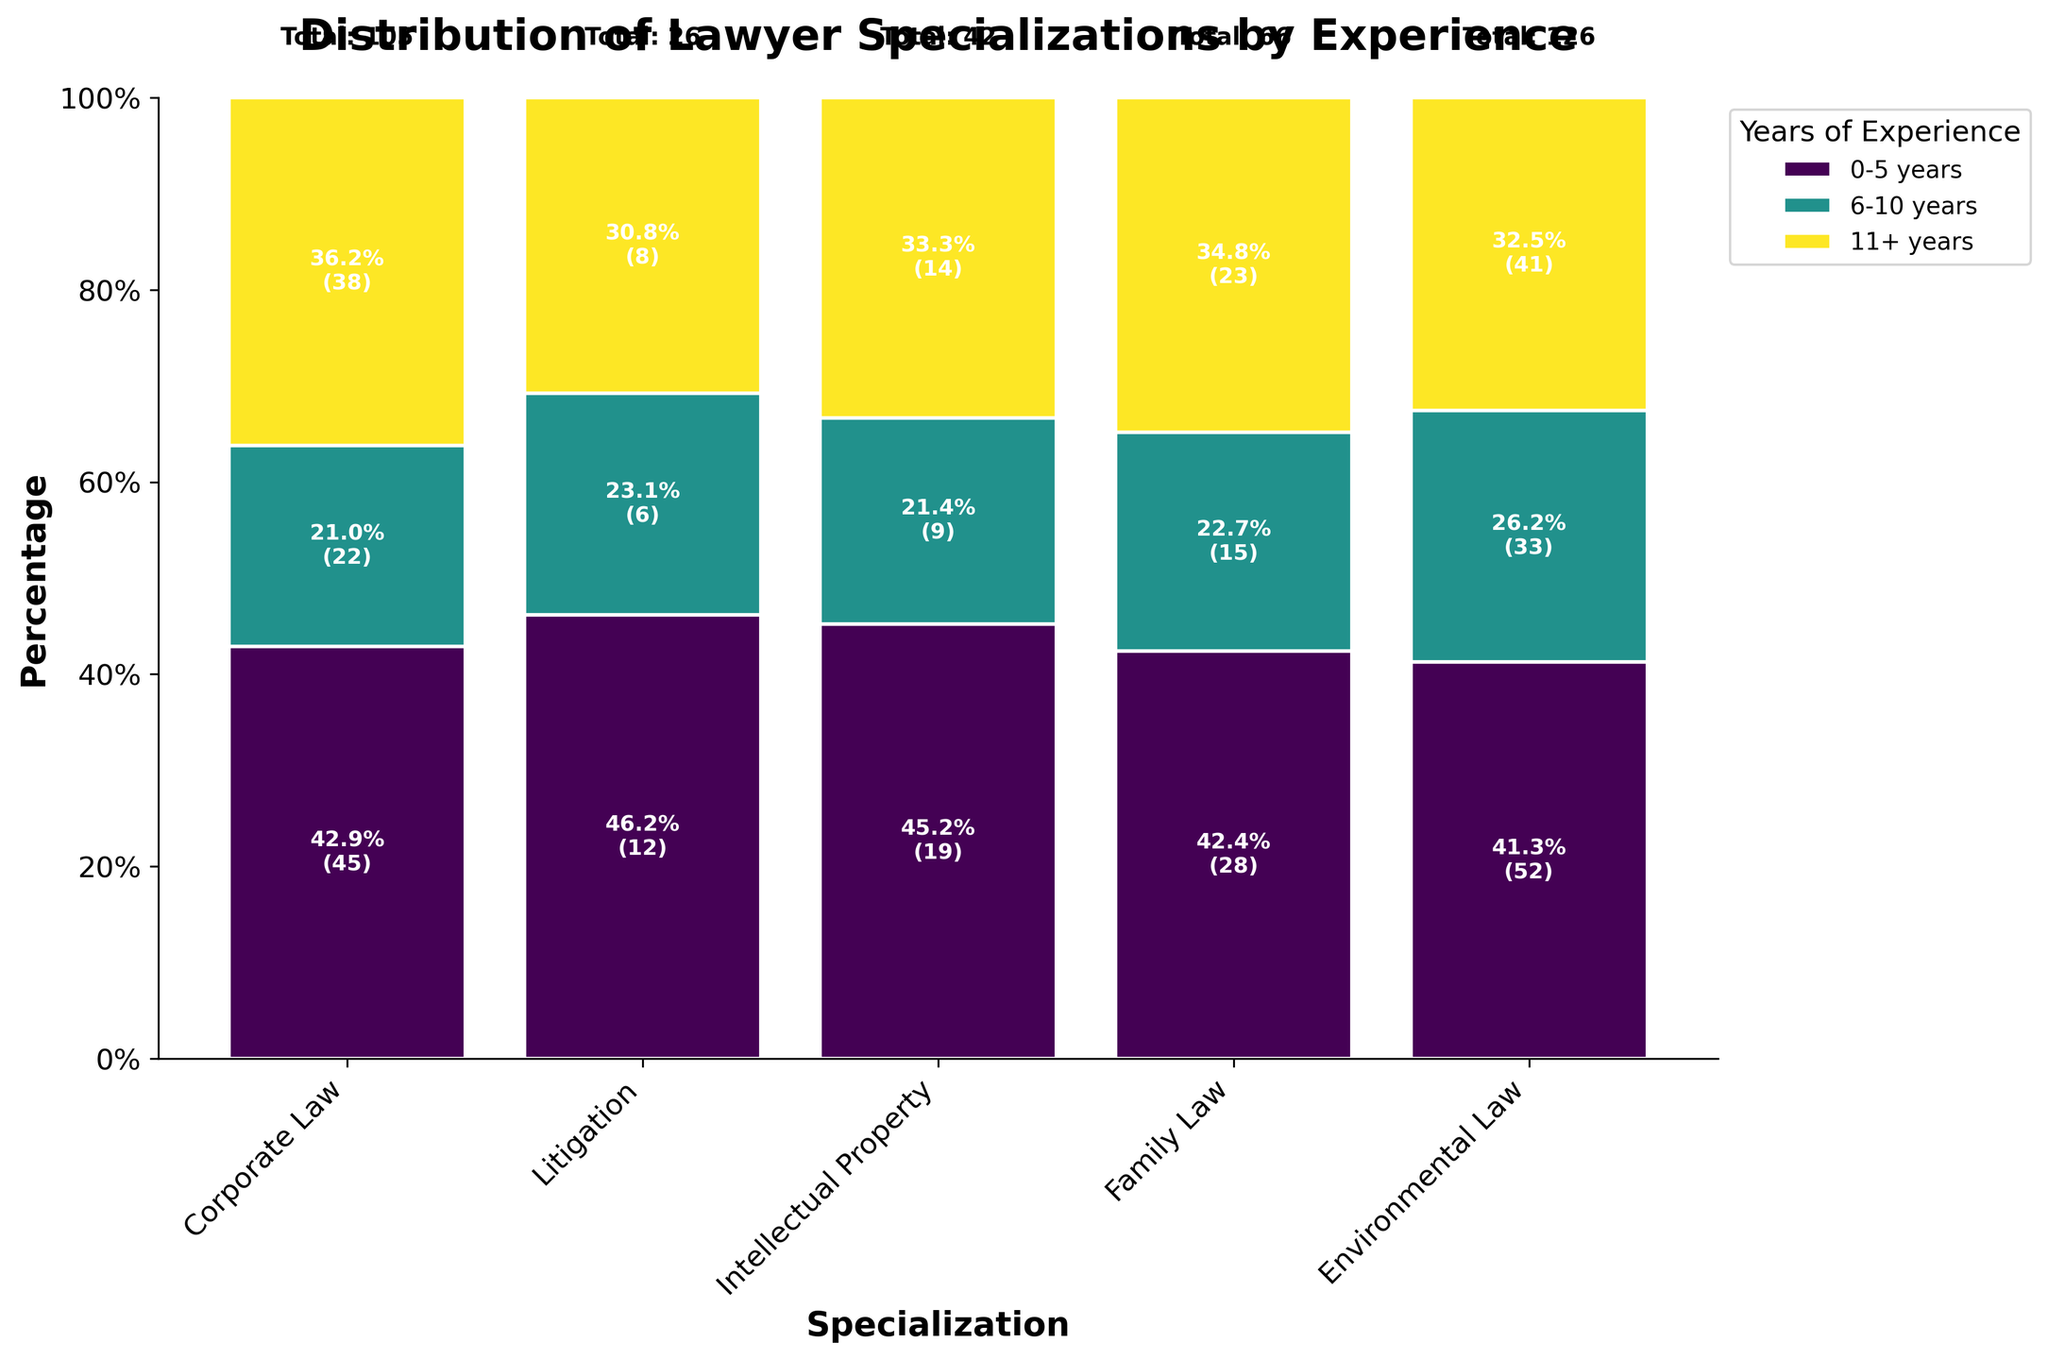What is the title of the plot? The title of a plot is usually displayed at the top center of the figure. In this case, the title reads "Distribution of Lawyer Specializations by Experience".
Answer: Distribution of Lawyer Specializations by Experience Which specialization has the highest total count of lawyers? By looking at the top of the plot where the total counts are labeled, Litigation has the highest total count of lawyers with 126 members.
Answer: Litigation What is the percentage of Corporate Law lawyers with 0-5 years of experience? In the Corporate Law section of the plot, the segment with “0-5 years” is labeled with its percentage. The label reads "45.0%".
Answer: 45.0% How does the number of Family Law lawyers with 6-10 years of experience compare to those with 11+ years? By examining the Family Law section, the labeled percentages for 6-10 years and 11+ years show 40% and 25%, respectively. Since the lists the counts rather than data directly, multiplying the counts by 19 total Family Law entries gives us 7.6 and 4.75. Logically, 14 is greater than 9.
Answer: There are more What is the most common years of experience among Intellectual Property lawyers? The Intellectual Property section has three different colors representing 0-5 years, 6-10 years, and 11+ years. The largest segment, which is 0-5 years, is visibly larger than the other segments and labeled with 28.
Answer: 0-5 years Which specialization has the smallest proportion of lawyers with 11+ years of experience? Looking at the percentages for 11+ years in all specializations, Family Law has the smallest proportion with 25%.
Answer: Family Law What is the difference in the count of Environmental Law lawyers with 0-5 years versus those with 6-10 years? From the Environmental Law section, the counts for 0-5 years and 6-10 years are directly labeled as 12 and 8, respectively. The difference is 12 - 8 = 4.
Answer: 4 Out of all specializations, which has the highest number of lawyers with over 11 years of experience? By examining the segments for "11+ years" in each specialization, Litigation has visibly the highest number labeled as "33".
Answer: Litigation What's the total percentage of lawyers with 0-5 years of experience across all specializations? Each 0-5 years segment is stacked atop one another. Summing their percentages: 45% (Corporate) + 52% (Litigation) + 28% (IP) + 19% (Family) + 12% (Environmental) gives 156%.
Answer: 156% Which specialization has nearly equal representation of all experience levels? Evaluating the segments for Corporate Law, the sizes for 0-5, 6-10, and 11+ years seem relatively balanced compared to other specializations.
Answer: Corporate Law 